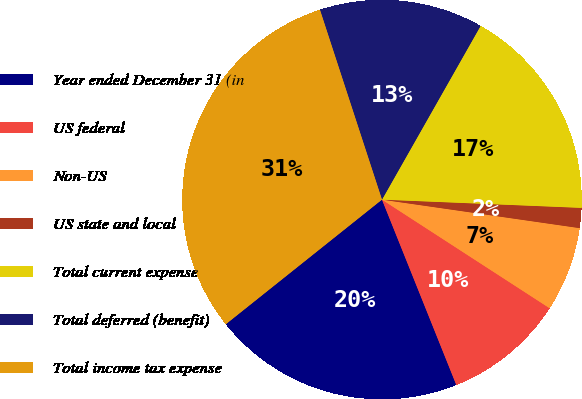Convert chart. <chart><loc_0><loc_0><loc_500><loc_500><pie_chart><fcel>Year ended December 31 (in<fcel>US federal<fcel>Non-US<fcel>US state and local<fcel>Total current expense<fcel>Total deferred (benefit)<fcel>Total income tax expense<nl><fcel>20.35%<fcel>9.78%<fcel>6.87%<fcel>1.62%<fcel>17.44%<fcel>13.24%<fcel>30.69%<nl></chart> 